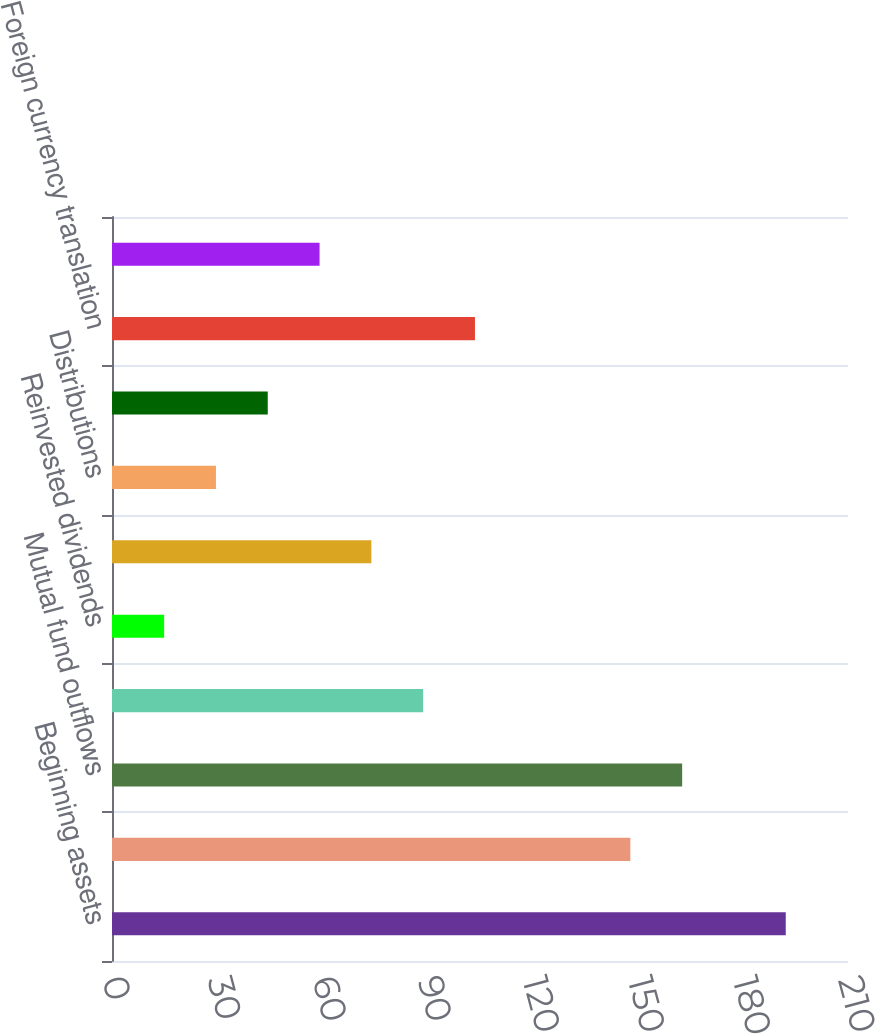Convert chart. <chart><loc_0><loc_0><loc_500><loc_500><bar_chart><fcel>Beginning assets<fcel>Mutual fund inflows<fcel>Mutual fund outflows<fcel>Net new flows<fcel>Reinvested dividends<fcel>Net flows<fcel>Distributions<fcel>Market appreciation<fcel>Foreign currency translation<fcel>Other<nl><fcel>192.24<fcel>147.9<fcel>162.68<fcel>88.78<fcel>14.88<fcel>74<fcel>29.66<fcel>44.44<fcel>103.56<fcel>59.22<nl></chart> 